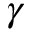<formula> <loc_0><loc_0><loc_500><loc_500>\gamma</formula> 